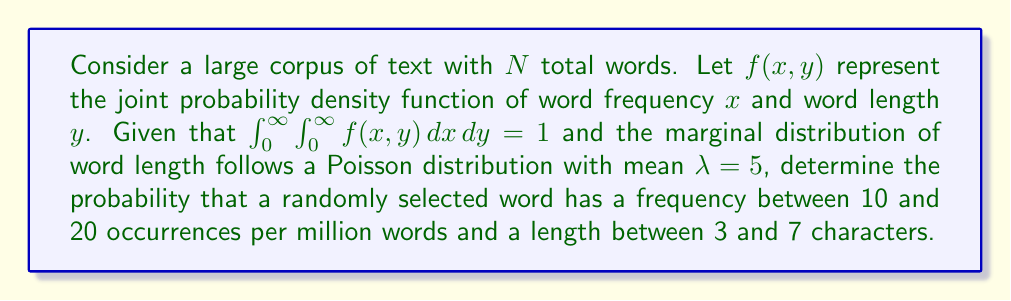Can you answer this question? To solve this problem, we'll follow these steps:

1) First, we need to understand the given information:
   - $f(x, y)$ is the joint probability density function of word frequency and length
   - The marginal distribution of word length follows a Poisson distribution with $\lambda = 5$

2) The Poisson probability mass function is given by:

   $$P(Y = k) = \frac{e^{-\lambda}\lambda^k}{k!}$$

3) To find the probability of a word having a length between 3 and 7 characters, we sum the Poisson probabilities:

   $$P(3 \leq Y \leq 7) = \sum_{k=3}^{7} \frac{e^{-5}5^k}{k!}$$

4) The frequency is given per million words, so we need to scale our bounds:
   10 per million = 0.00001
   20 per million = 0.00002

5) The probability we're looking for is represented by a double integral:

   $$P(0.00001 \leq X \leq 0.00002, 3 \leq Y \leq 7) = \int_{3}^{7}\int_{0.00001}^{0.00002} f(x, y) \, dx \, dy$$

6) Without knowing the exact form of $f(x, y)$, we can't evaluate this integral directly. However, if we assume independence between word frequency and length (which is a simplification), we can write:

   $$P(0.00001 \leq X \leq 0.00002, 3 \leq Y \leq 7) = P(0.00001 \leq X \leq 0.00002) \cdot P(3 \leq Y \leq 7)$$

7) We've already calculated $P(3 \leq Y \leq 7)$ in step 3. For $P(0.00001 \leq X \leq 0.00002)$, we would need more information about the distribution of word frequencies.

8) In a real-world scenario, you would need to analyze the corpus to determine $f(x, y)$ or make assumptions about its form based on linguistic theory or empirical observations.
Answer: Without the full joint probability density function $f(x, y)$, we cannot provide a numerical answer. However, the probability can be expressed as:

$$P(0.00001 \leq X \leq 0.00002, 3 \leq Y \leq 7) = \int_{3}^{7}\int_{0.00001}^{0.00002} f(x, y) \, dx \, dy$$

If word frequency and length are assumed independent, this simplifies to:

$$P(0.00001 \leq X \leq 0.00002) \cdot \sum_{k=3}^{7} \frac{e^{-5}5^k}{k!}$$

where $P(0.00001 \leq X \leq 0.00002)$ would need to be determined from the word frequency distribution in the corpus. 